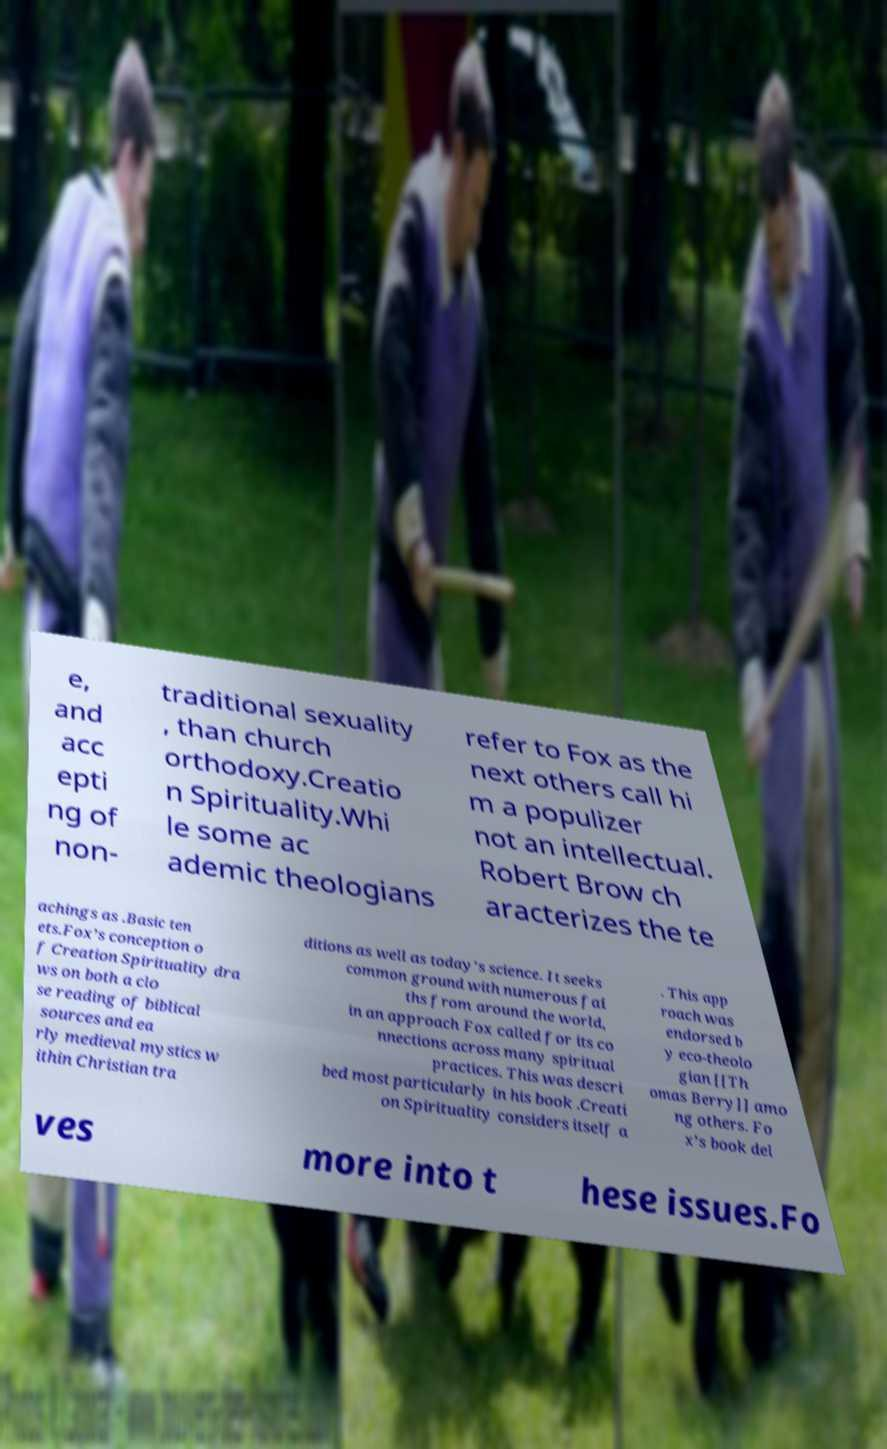Can you accurately transcribe the text from the provided image for me? e, and acc epti ng of non- traditional sexuality , than church orthodoxy.Creatio n Spirituality.Whi le some ac ademic theologians refer to Fox as the next others call hi m a populizer not an intellectual. Robert Brow ch aracterizes the te achings as .Basic ten ets.Fox’s conception o f Creation Spirituality dra ws on both a clo se reading of biblical sources and ea rly medieval mystics w ithin Christian tra ditions as well as today's science. It seeks common ground with numerous fai ths from around the world, in an approach Fox called for its co nnections across many spiritual practices. This was descri bed most particularly in his book .Creati on Spirituality considers itself a . This app roach was endorsed b y eco-theolo gian [[Th omas Berry]] amo ng others. Fo x’s book del ves more into t hese issues.Fo 